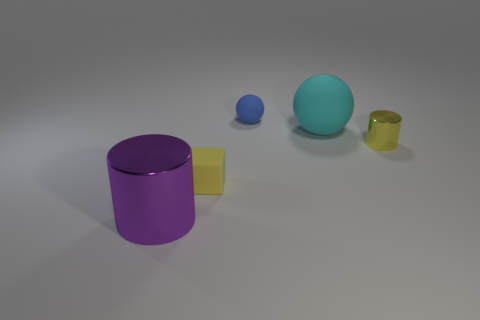There is a tiny object that is the same color as the cube; what shape is it?
Offer a terse response. Cylinder. What shape is the metallic object that is on the right side of the small rubber cube?
Your response must be concise. Cylinder. Is there a block made of the same material as the big cyan object?
Your answer should be very brief. Yes. Do the cylinder that is right of the large purple cylinder and the cube have the same color?
Give a very brief answer. Yes. The blue ball has what size?
Make the answer very short. Small. Is there a small yellow rubber block that is in front of the metal object behind the cylinder to the left of the tiny rubber sphere?
Provide a short and direct response. Yes. What number of matte balls are behind the cyan matte thing?
Provide a succinct answer. 1. How many cylinders have the same color as the matte block?
Give a very brief answer. 1. How many things are either cylinders that are behind the tiny yellow rubber object or matte things to the right of the small yellow matte block?
Your response must be concise. 3. Are there more small yellow matte blocks than large things?
Keep it short and to the point. No. 